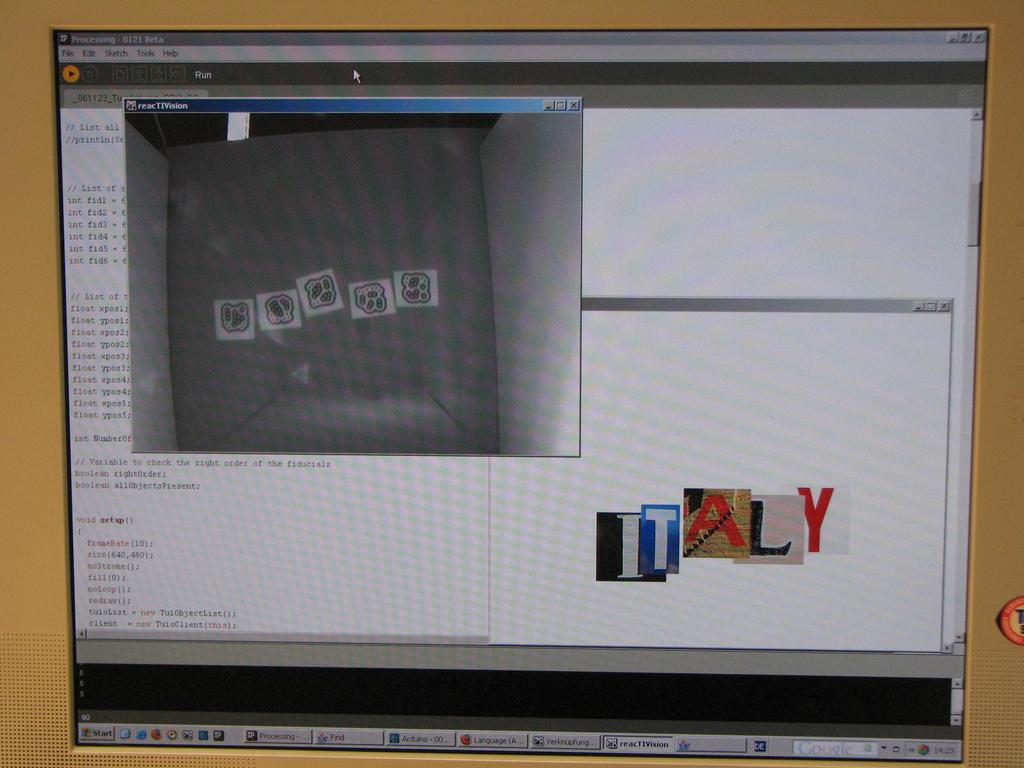Which company is shown on the bottom right?
Your answer should be very brief. Italy. 